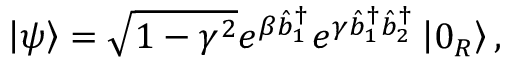Convert formula to latex. <formula><loc_0><loc_0><loc_500><loc_500>\left | \psi \right \rangle = \sqrt { 1 - \gamma ^ { 2 } } e ^ { \beta \hat { b } _ { 1 } ^ { \dagger } } e ^ { \gamma \hat { b } _ { 1 } ^ { \dagger } \hat { b } _ { 2 } ^ { \dagger } } \left | 0 _ { R } \right \rangle ,</formula> 